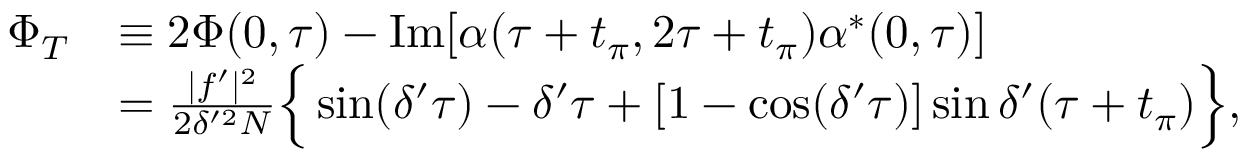Convert formula to latex. <formula><loc_0><loc_0><loc_500><loc_500>\begin{array} { r l } { \Phi _ { T } } & { \equiv 2 \Phi ( 0 , \tau ) - I m [ \alpha ( \tau + t _ { \pi } , 2 \tau + t _ { \pi } ) \alpha ^ { \ast } ( 0 , \tau ) ] } \\ & { = \frac { | f ^ { \prime } | ^ { 2 } } { 2 \delta ^ { \prime 2 } N } \left \{ \sin ( \delta ^ { \prime } \tau ) - \delta ^ { \prime } \tau + [ 1 - \cos ( \delta ^ { \prime } \tau ) ] \sin \delta ^ { \prime } ( \tau + t _ { \pi } ) \right \} , } \end{array}</formula> 